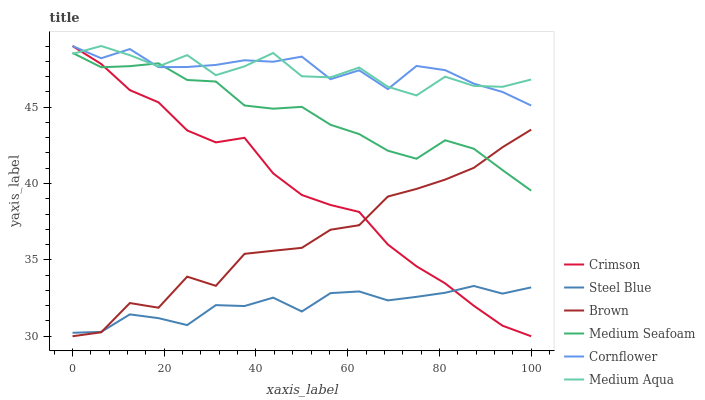Does Steel Blue have the minimum area under the curve?
Answer yes or no. Yes. Does Cornflower have the maximum area under the curve?
Answer yes or no. Yes. Does Cornflower have the minimum area under the curve?
Answer yes or no. No. Does Steel Blue have the maximum area under the curve?
Answer yes or no. No. Is Crimson the smoothest?
Answer yes or no. Yes. Is Brown the roughest?
Answer yes or no. Yes. Is Cornflower the smoothest?
Answer yes or no. No. Is Cornflower the roughest?
Answer yes or no. No. Does Brown have the lowest value?
Answer yes or no. Yes. Does Cornflower have the lowest value?
Answer yes or no. No. Does Crimson have the highest value?
Answer yes or no. Yes. Does Steel Blue have the highest value?
Answer yes or no. No. Is Steel Blue less than Medium Aqua?
Answer yes or no. Yes. Is Cornflower greater than Steel Blue?
Answer yes or no. Yes. Does Crimson intersect Cornflower?
Answer yes or no. Yes. Is Crimson less than Cornflower?
Answer yes or no. No. Is Crimson greater than Cornflower?
Answer yes or no. No. Does Steel Blue intersect Medium Aqua?
Answer yes or no. No. 